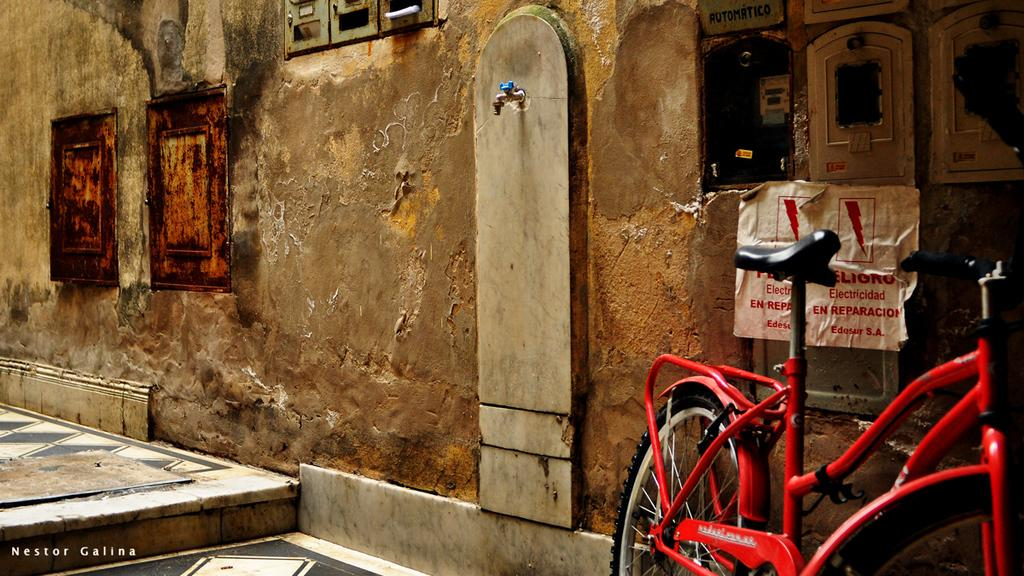What is the main object in the image? There is a cycle in the image. Where is the cycle located in relation to other objects? The cycle is beside a wall. What can be seen at the top of the image? There is a tap at the top of the image. What is present in the top right corner of the image? There are panels in the top right of the image. What type of chair is depicted in the image? There is no chair present in the image. What is the nature of the argument taking place in the image? There is no argument present in the image; it features a cycle, a wall, a tap, and panels. 